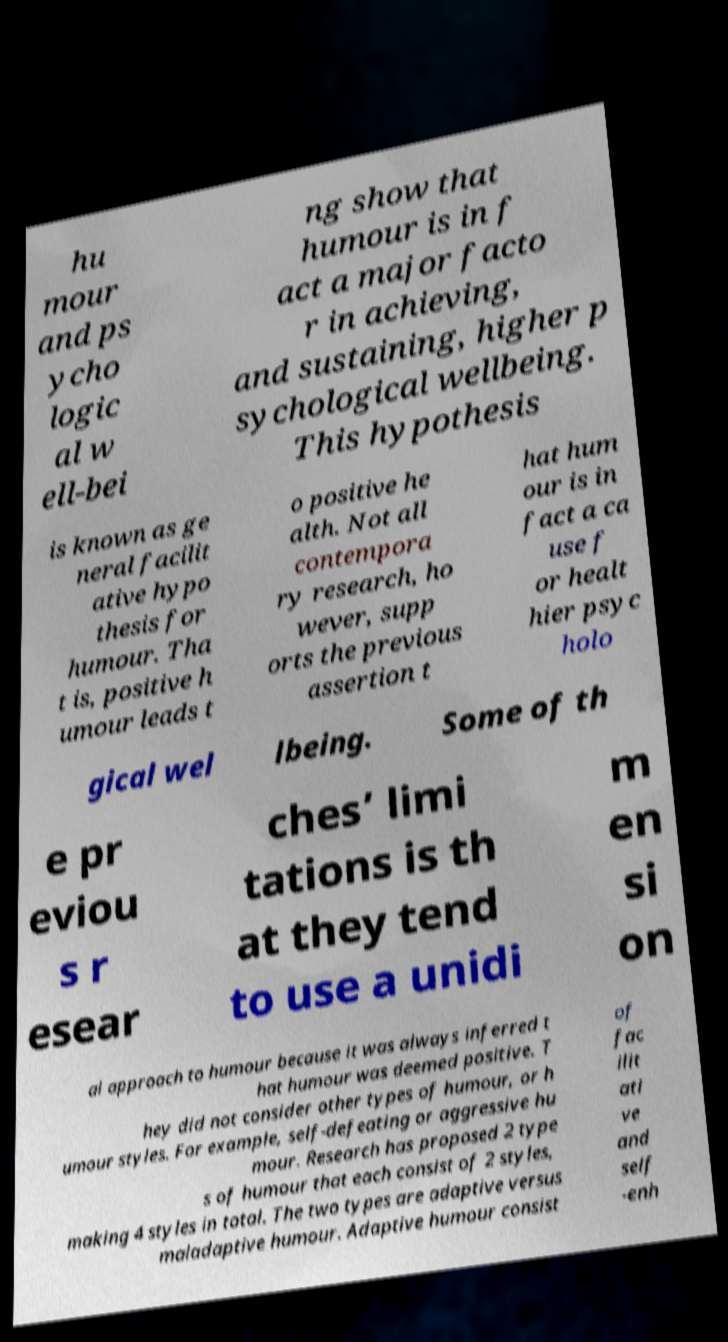For documentation purposes, I need the text within this image transcribed. Could you provide that? hu mour and ps ycho logic al w ell-bei ng show that humour is in f act a major facto r in achieving, and sustaining, higher p sychological wellbeing. This hypothesis is known as ge neral facilit ative hypo thesis for humour. Tha t is, positive h umour leads t o positive he alth. Not all contempora ry research, ho wever, supp orts the previous assertion t hat hum our is in fact a ca use f or healt hier psyc holo gical wel lbeing. Some of th e pr eviou s r esear ches’ limi tations is th at they tend to use a unidi m en si on al approach to humour because it was always inferred t hat humour was deemed positive. T hey did not consider other types of humour, or h umour styles. For example, self-defeating or aggressive hu mour. Research has proposed 2 type s of humour that each consist of 2 styles, making 4 styles in total. The two types are adaptive versus maladaptive humour. Adaptive humour consist of fac ilit ati ve and self -enh 